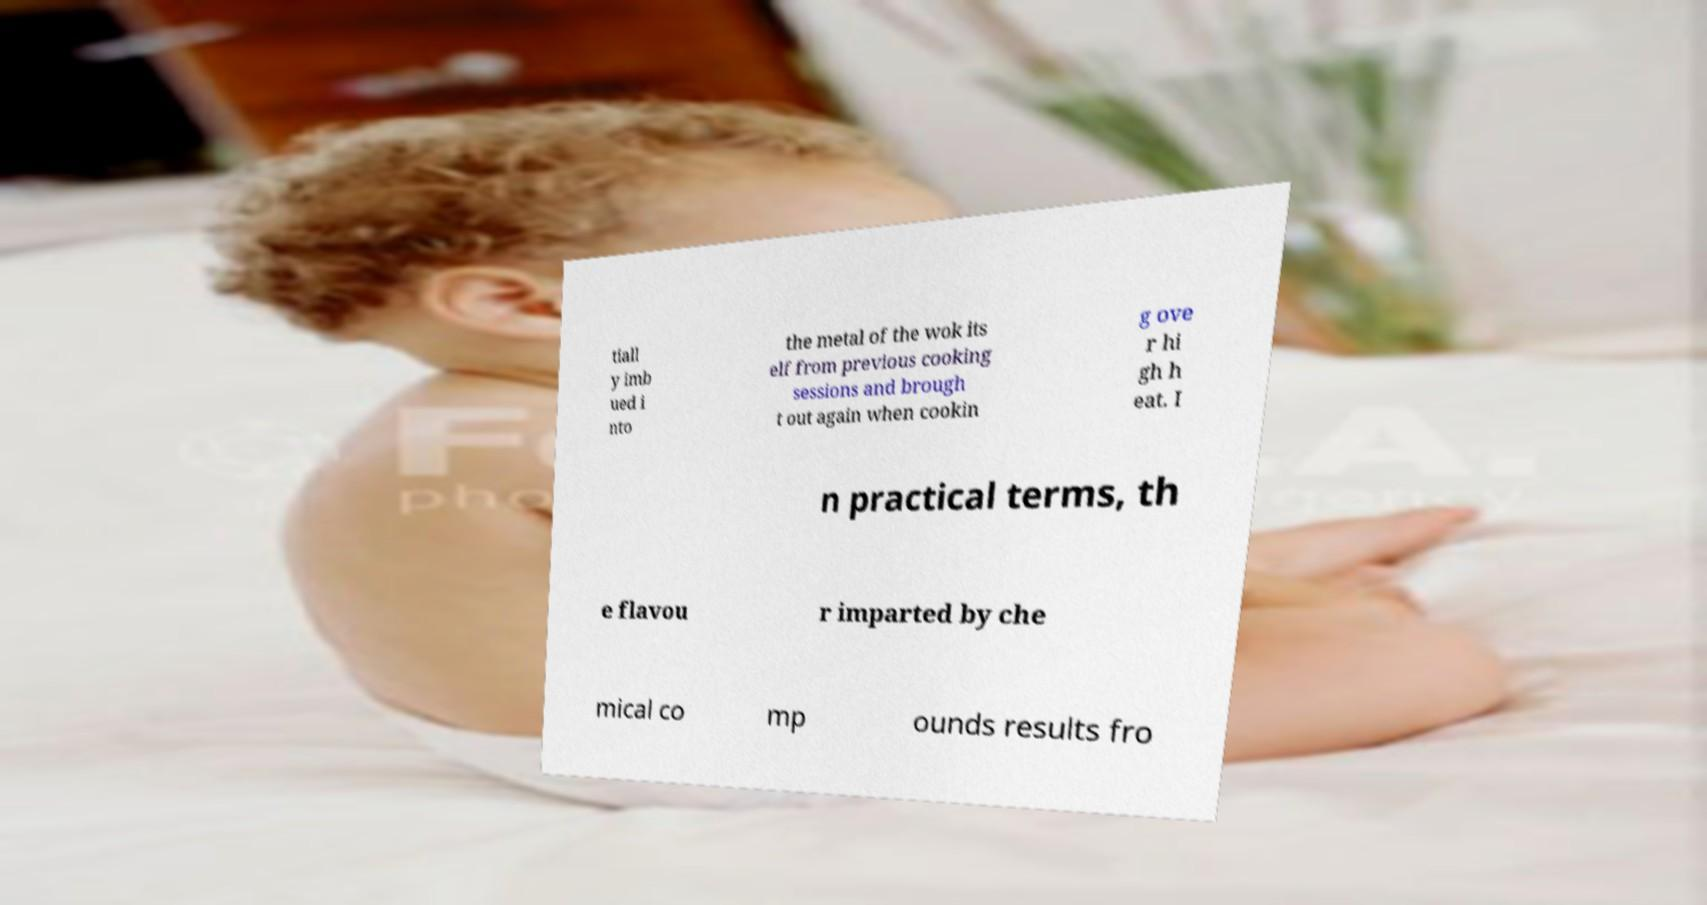For documentation purposes, I need the text within this image transcribed. Could you provide that? tiall y imb ued i nto the metal of the wok its elf from previous cooking sessions and brough t out again when cookin g ove r hi gh h eat. I n practical terms, th e flavou r imparted by che mical co mp ounds results fro 